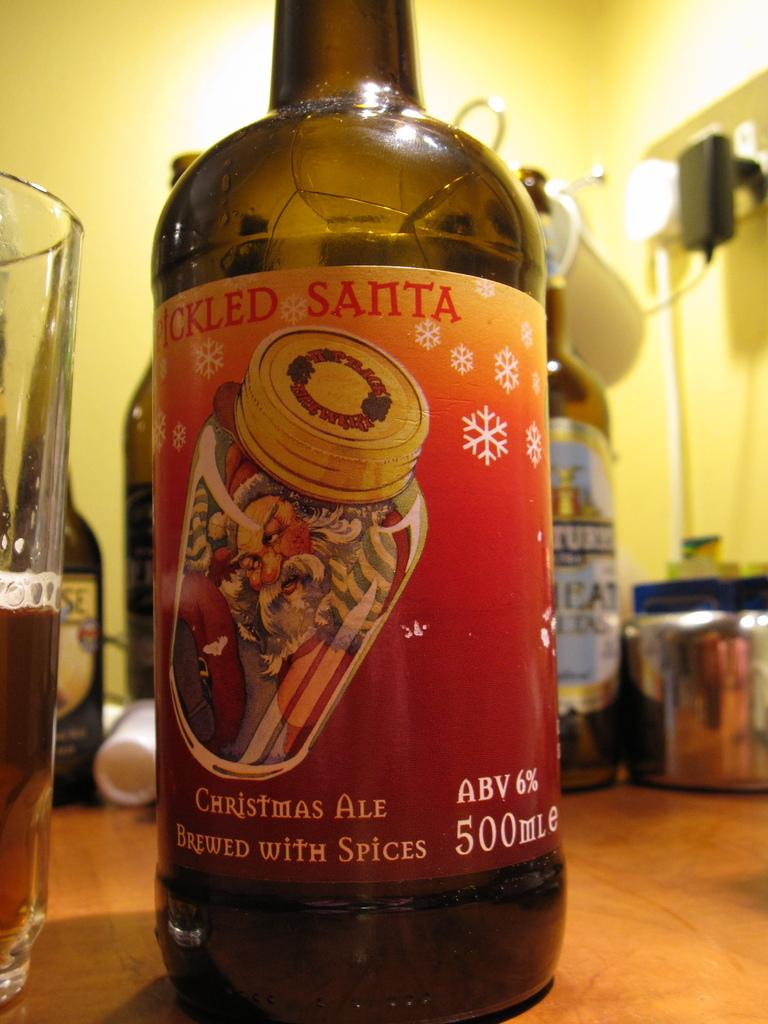<image>
Summarize the visual content of the image. A bottle of Picked Santa christmas ale sits on a table 